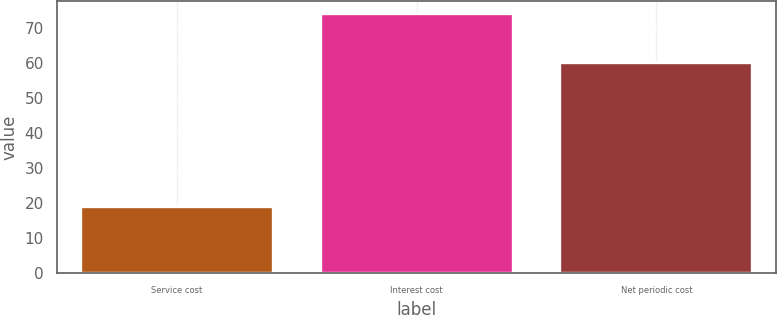<chart> <loc_0><loc_0><loc_500><loc_500><bar_chart><fcel>Service cost<fcel>Interest cost<fcel>Net periodic cost<nl><fcel>19<fcel>74<fcel>60<nl></chart> 